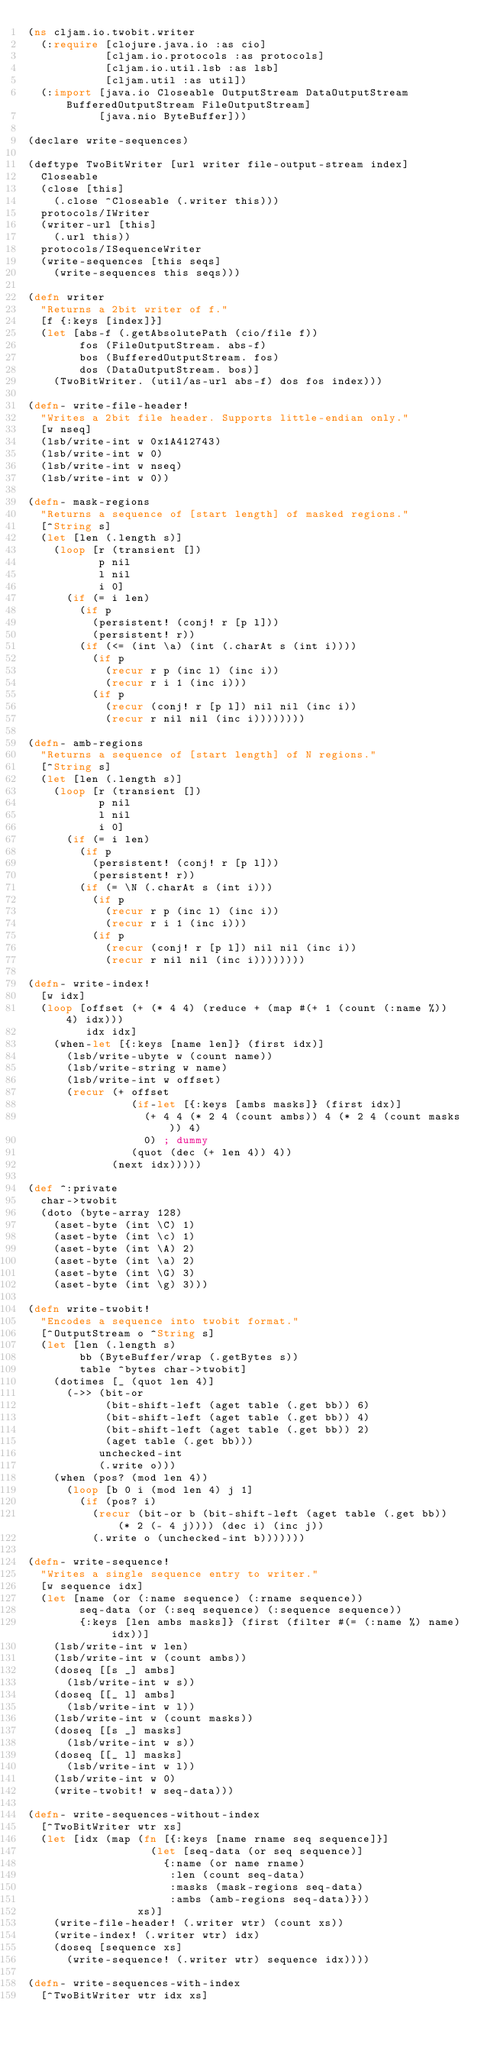<code> <loc_0><loc_0><loc_500><loc_500><_Clojure_>(ns cljam.io.twobit.writer
  (:require [clojure.java.io :as cio]
            [cljam.io.protocols :as protocols]
            [cljam.io.util.lsb :as lsb]
            [cljam.util :as util])
  (:import [java.io Closeable OutputStream DataOutputStream BufferedOutputStream FileOutputStream]
           [java.nio ByteBuffer]))

(declare write-sequences)

(deftype TwoBitWriter [url writer file-output-stream index]
  Closeable
  (close [this]
    (.close ^Closeable (.writer this)))
  protocols/IWriter
  (writer-url [this]
    (.url this))
  protocols/ISequenceWriter
  (write-sequences [this seqs]
    (write-sequences this seqs)))

(defn writer
  "Returns a 2bit writer of f."
  [f {:keys [index]}]
  (let [abs-f (.getAbsolutePath (cio/file f))
        fos (FileOutputStream. abs-f)
        bos (BufferedOutputStream. fos)
        dos (DataOutputStream. bos)]
    (TwoBitWriter. (util/as-url abs-f) dos fos index)))

(defn- write-file-header!
  "Writes a 2bit file header. Supports little-endian only."
  [w nseq]
  (lsb/write-int w 0x1A412743)
  (lsb/write-int w 0)
  (lsb/write-int w nseq)
  (lsb/write-int w 0))

(defn- mask-regions
  "Returns a sequence of [start length] of masked regions."
  [^String s]
  (let [len (.length s)]
    (loop [r (transient [])
           p nil
           l nil
           i 0]
      (if (= i len)
        (if p
          (persistent! (conj! r [p l]))
          (persistent! r))
        (if (<= (int \a) (int (.charAt s (int i))))
          (if p
            (recur r p (inc l) (inc i))
            (recur r i 1 (inc i)))
          (if p
            (recur (conj! r [p l]) nil nil (inc i))
            (recur r nil nil (inc i))))))))

(defn- amb-regions
  "Returns a sequence of [start length] of N regions."
  [^String s]
  (let [len (.length s)]
    (loop [r (transient [])
           p nil
           l nil
           i 0]
      (if (= i len)
        (if p
          (persistent! (conj! r [p l]))
          (persistent! r))
        (if (= \N (.charAt s (int i)))
          (if p
            (recur r p (inc l) (inc i))
            (recur r i 1 (inc i)))
          (if p
            (recur (conj! r [p l]) nil nil (inc i))
            (recur r nil nil (inc i))))))))

(defn- write-index!
  [w idx]
  (loop [offset (+ (* 4 4) (reduce + (map #(+ 1 (count (:name %)) 4) idx)))
         idx idx]
    (when-let [{:keys [name len]} (first idx)]
      (lsb/write-ubyte w (count name))
      (lsb/write-string w name)
      (lsb/write-int w offset)
      (recur (+ offset
                (if-let [{:keys [ambs masks]} (first idx)]
                  (+ 4 4 (* 2 4 (count ambs)) 4 (* 2 4 (count masks)) 4)
                  0) ; dummy
                (quot (dec (+ len 4)) 4))
             (next idx)))))

(def ^:private
  char->twobit
  (doto (byte-array 128)
    (aset-byte (int \C) 1)
    (aset-byte (int \c) 1)
    (aset-byte (int \A) 2)
    (aset-byte (int \a) 2)
    (aset-byte (int \G) 3)
    (aset-byte (int \g) 3)))

(defn write-twobit!
  "Encodes a sequence into twobit format."
  [^OutputStream o ^String s]
  (let [len (.length s)
        bb (ByteBuffer/wrap (.getBytes s))
        table ^bytes char->twobit]
    (dotimes [_ (quot len 4)]
      (->> (bit-or
            (bit-shift-left (aget table (.get bb)) 6)
            (bit-shift-left (aget table (.get bb)) 4)
            (bit-shift-left (aget table (.get bb)) 2)
            (aget table (.get bb)))
           unchecked-int
           (.write o)))
    (when (pos? (mod len 4))
      (loop [b 0 i (mod len 4) j 1]
        (if (pos? i)
          (recur (bit-or b (bit-shift-left (aget table (.get bb)) (* 2 (- 4 j)))) (dec i) (inc j))
          (.write o (unchecked-int b)))))))

(defn- write-sequence!
  "Writes a single sequence entry to writer."
  [w sequence idx]
  (let [name (or (:name sequence) (:rname sequence))
        seq-data (or (:seq sequence) (:sequence sequence))
        {:keys [len ambs masks]} (first (filter #(= (:name %) name) idx))]
    (lsb/write-int w len)
    (lsb/write-int w (count ambs))
    (doseq [[s _] ambs]
      (lsb/write-int w s))
    (doseq [[_ l] ambs]
      (lsb/write-int w l))
    (lsb/write-int w (count masks))
    (doseq [[s _] masks]
      (lsb/write-int w s))
    (doseq [[_ l] masks]
      (lsb/write-int w l))
    (lsb/write-int w 0)
    (write-twobit! w seq-data)))

(defn- write-sequences-without-index
  [^TwoBitWriter wtr xs]
  (let [idx (map (fn [{:keys [name rname seq sequence]}]
                   (let [seq-data (or seq sequence)]
                     {:name (or name rname)
                      :len (count seq-data)
                      :masks (mask-regions seq-data)
                      :ambs (amb-regions seq-data)}))
                 xs)]
    (write-file-header! (.writer wtr) (count xs))
    (write-index! (.writer wtr) idx)
    (doseq [sequence xs]
      (write-sequence! (.writer wtr) sequence idx))))

(defn- write-sequences-with-index
  [^TwoBitWriter wtr idx xs]</code> 